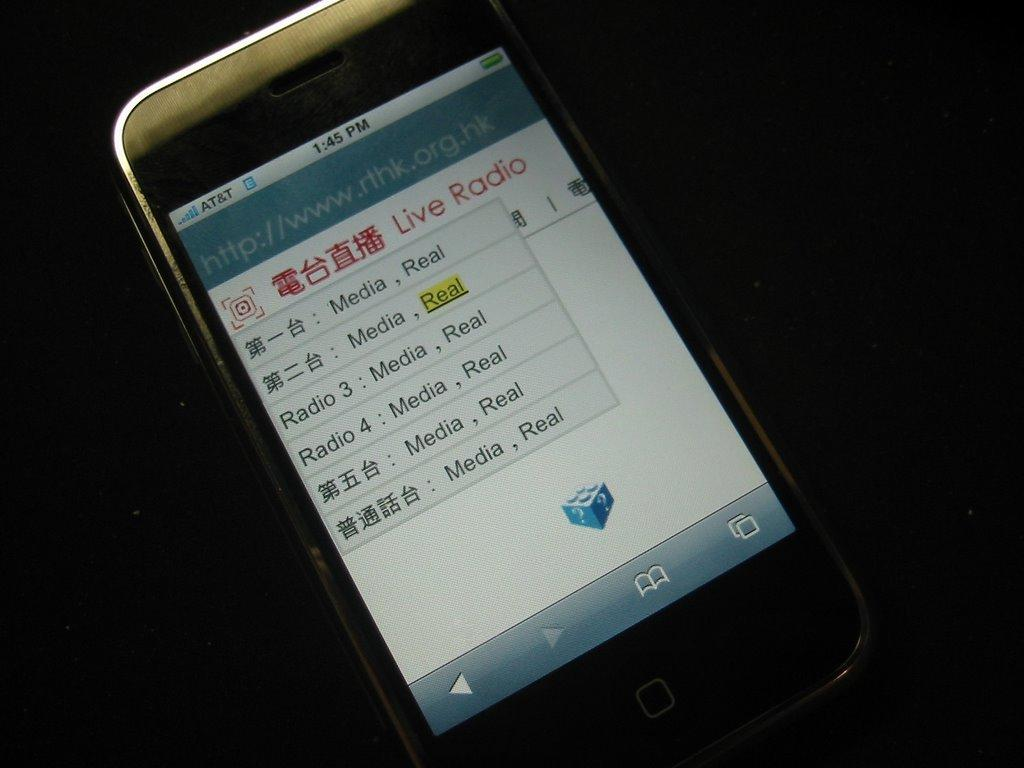Provide a one-sentence caption for the provided image. a phone with service from at&t showing Live Radio on the screen. 